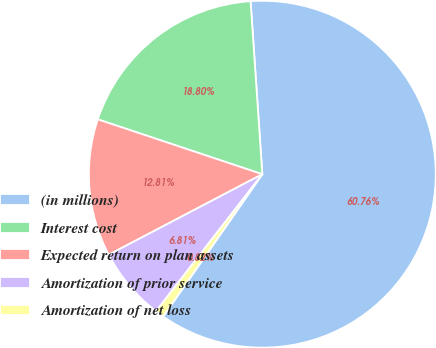Convert chart to OTSL. <chart><loc_0><loc_0><loc_500><loc_500><pie_chart><fcel>(in millions)<fcel>Interest cost<fcel>Expected return on plan assets<fcel>Amortization of prior service<fcel>Amortization of net loss<nl><fcel>60.77%<fcel>18.8%<fcel>12.81%<fcel>6.81%<fcel>0.82%<nl></chart> 